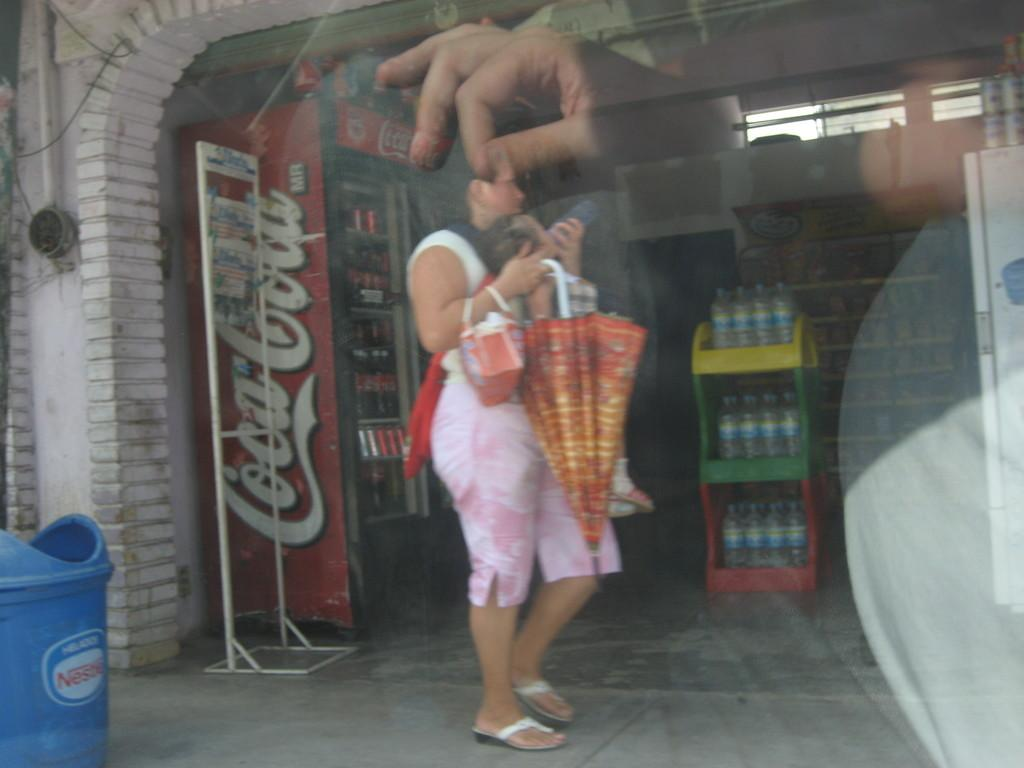<image>
Give a short and clear explanation of the subsequent image. A woman holding an upside down umbrella and handbag stands perpendicular to the camera outside a store front near a Coca Cola machine. 